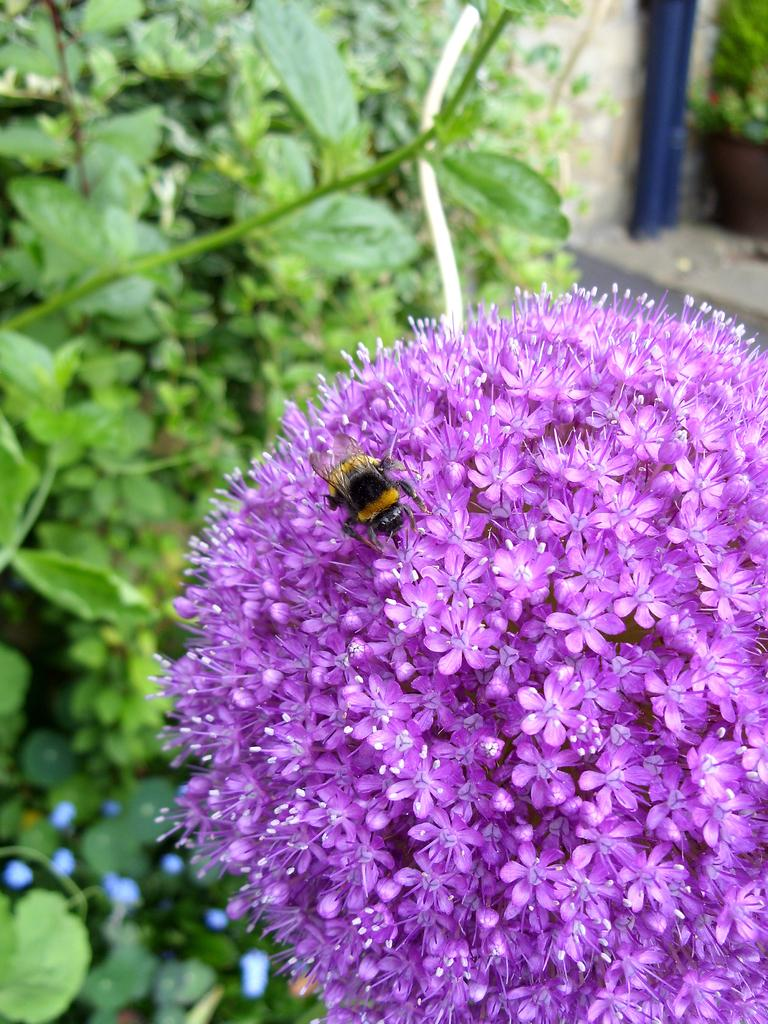What is the main subject of the image? The main subject of the image is a bunch of flowers. Is there anything else present on the flowers? Yes, there is a bee on the flowers. What other types of plants can be seen in the image? There are plants visible in the image. What is the background of the image? There is a wall in the image. What type of skirt can be seen near the ocean in the image? There is no skirt or ocean present in the image; it features a bunch of flowers with a bee and plants in front of a wall. 